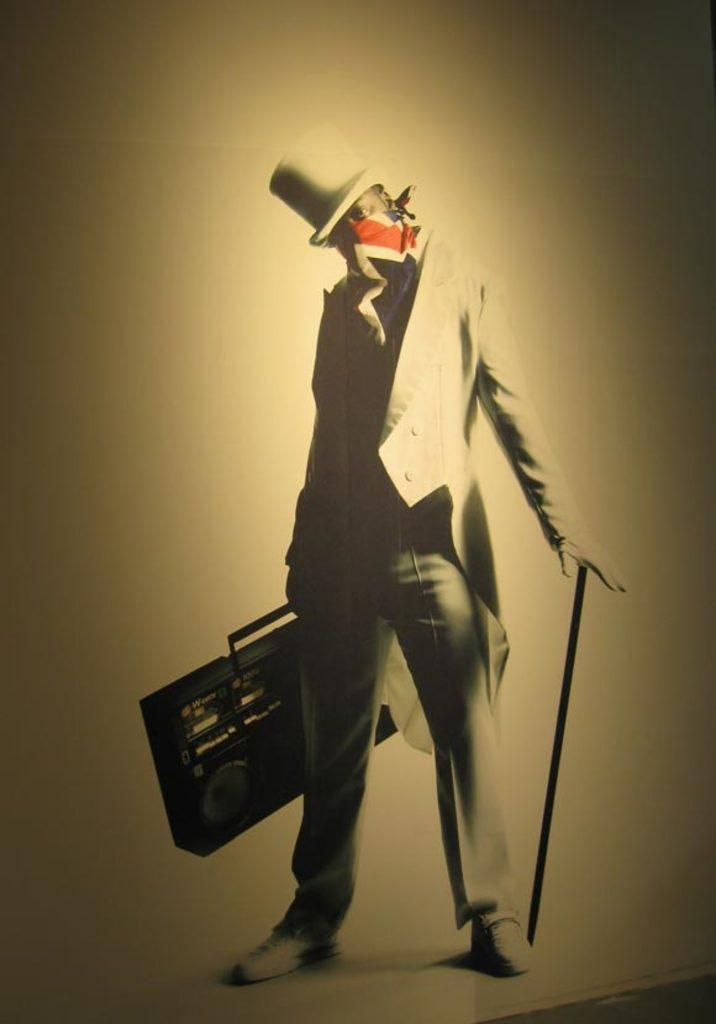What is the main subject of the image? There is a person in the center of the image. What type of clothing is the person wearing? The person is wearing a coat, a scarf, and a hat. What objects is the person holding? The person is holding a radio and a stick. What can be seen in the background of the image? There is a wall in the background of the image. What type of yoke is the person using to carry the radio and stick? There is no yoke present in the image; the person is simply holding the radio and stick. Can you tell me where the faucet is located in the image? There is no faucet present in the image. 